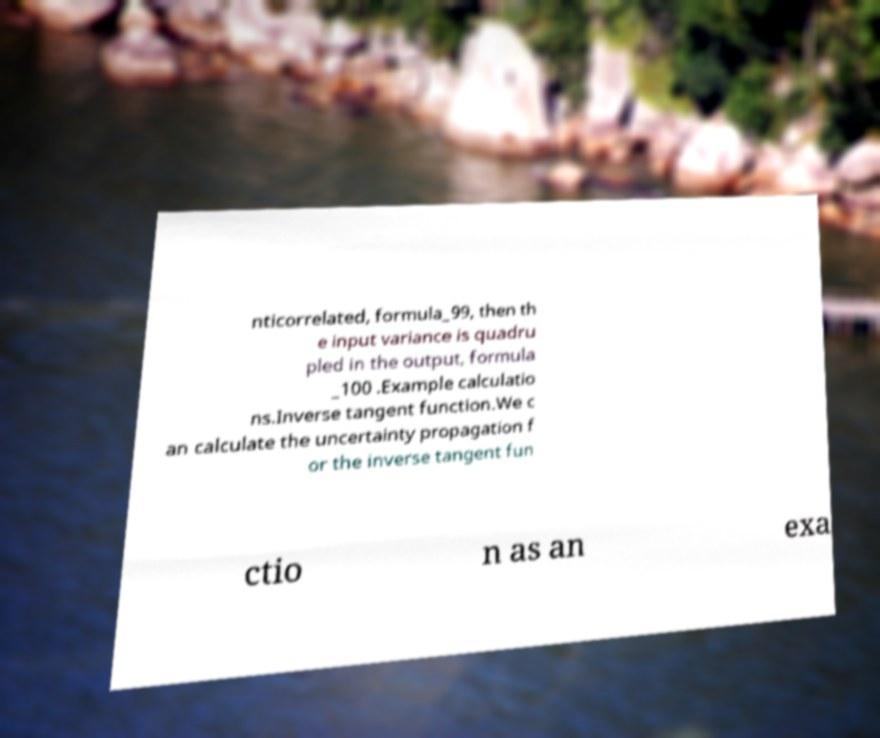There's text embedded in this image that I need extracted. Can you transcribe it verbatim? nticorrelated, formula_99, then th e input variance is quadru pled in the output, formula _100 .Example calculatio ns.Inverse tangent function.We c an calculate the uncertainty propagation f or the inverse tangent fun ctio n as an exa 